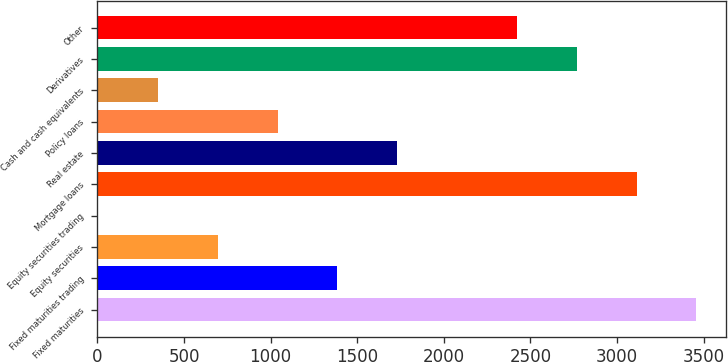<chart> <loc_0><loc_0><loc_500><loc_500><bar_chart><fcel>Fixed maturities<fcel>Fixed maturities trading<fcel>Equity securities<fcel>Equity securities trading<fcel>Mortgage loans<fcel>Real estate<fcel>Policy loans<fcel>Cash and cash equivalents<fcel>Derivatives<fcel>Other<nl><fcel>3458.3<fcel>1385.96<fcel>695.18<fcel>4.4<fcel>3112.91<fcel>1731.35<fcel>1040.57<fcel>349.79<fcel>2767.52<fcel>2422.13<nl></chart> 